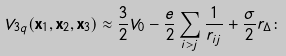Convert formula to latex. <formula><loc_0><loc_0><loc_500><loc_500>V _ { 3 q } ( { \mathbf x } _ { 1 } , { \mathbf x } _ { 2 } , { \mathbf x } _ { 3 } ) \approx \frac { 3 } { 2 } V _ { 0 } - \frac { e } { 2 } \sum _ { i > j } \frac { 1 } { r _ { i j } } + \frac { \sigma } { 2 } r _ { \Delta } \colon</formula> 